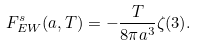<formula> <loc_0><loc_0><loc_500><loc_500>F _ { E W } ^ { s } ( a , T ) = - \frac { T } { 8 \pi a ^ { 3 } } \zeta ( 3 ) .</formula> 